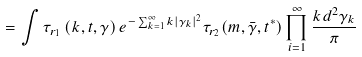<formula> <loc_0><loc_0><loc_500><loc_500>= \int \tau _ { r _ { 1 } } \left ( k , { t } , { \gamma } \right ) e ^ { - \sum _ { k = 1 } ^ { \infty } k | \gamma _ { k } | ^ { 2 } } \tau _ { r _ { 2 } } ( m , { \bar { \gamma } } , { t ^ { * } } ) \prod _ { i = 1 } ^ { \infty } \frac { k d ^ { 2 } \gamma _ { k } } { \pi }</formula> 